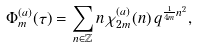Convert formula to latex. <formula><loc_0><loc_0><loc_500><loc_500>\Phi _ { m } ^ { ( a ) } ( \tau ) = \sum _ { n \in \mathbb { Z } } n \, \chi _ { 2 m } ^ { ( a ) } ( n ) \, q ^ { \frac { 1 } { 4 m } n ^ { 2 } } ,</formula> 